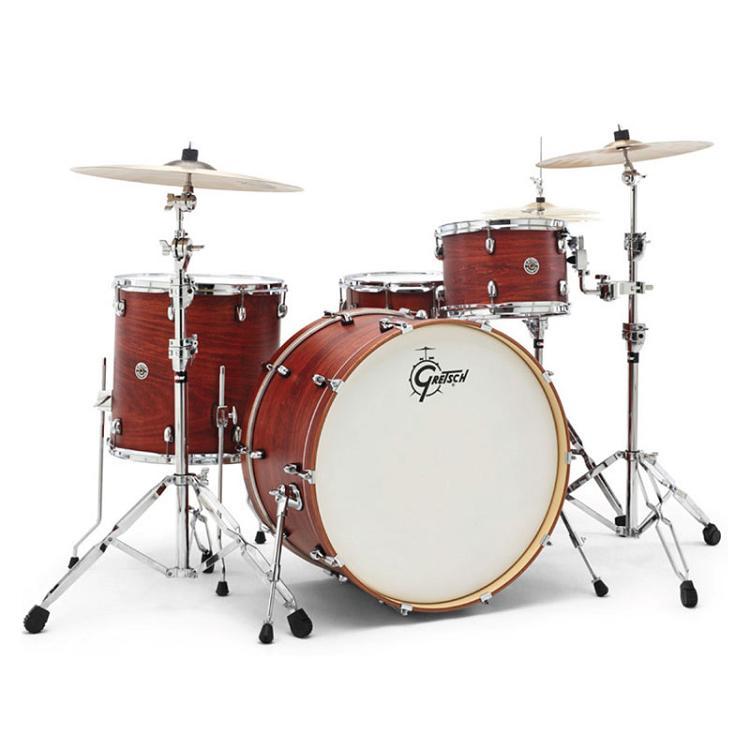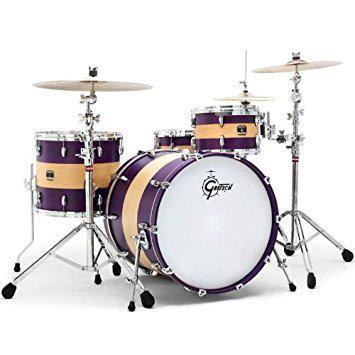The first image is the image on the left, the second image is the image on the right. For the images shown, is this caption "One set of drums has black sides and is flanked by two cymbals per side, and the other set of drums has wood-grain sides and is flanked by one cymbal per side." true? Answer yes or no. No. The first image is the image on the left, the second image is the image on the right. Assess this claim about the two images: "A drum set is placed on a white carpet in front of a black background in one of the pictures.". Correct or not? Answer yes or no. No. 